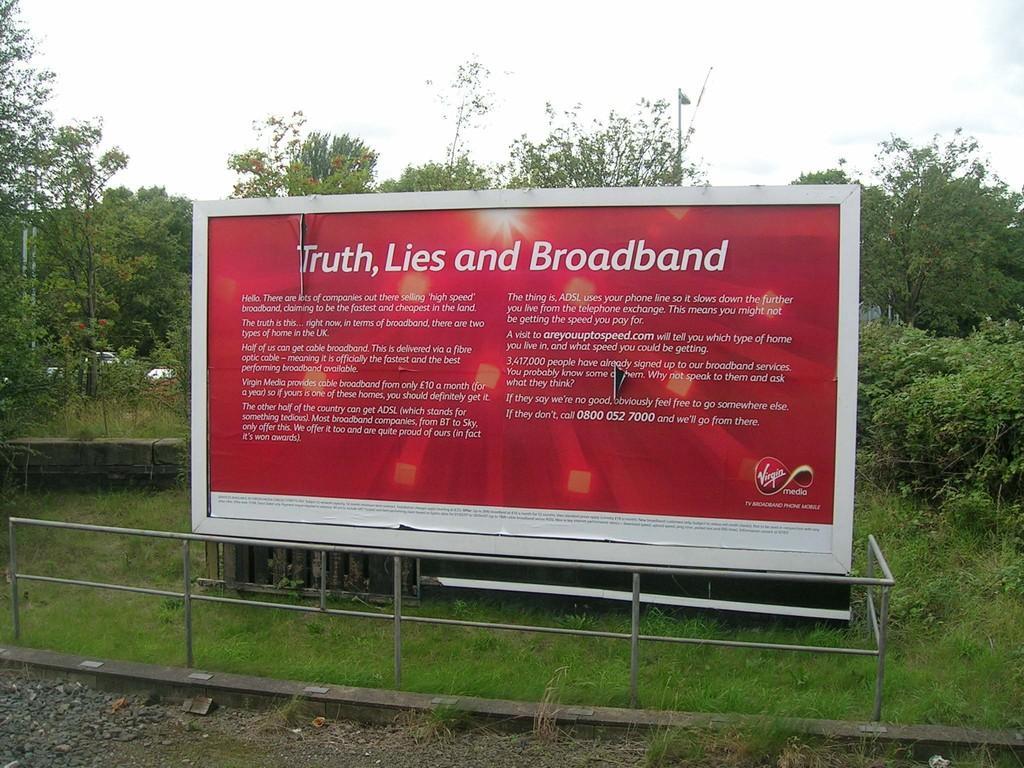Describe this image in one or two sentences. In this image I see a board on which there are words written and I see the green grass and I see the railing over here. In the background I see the trees and the sky. 